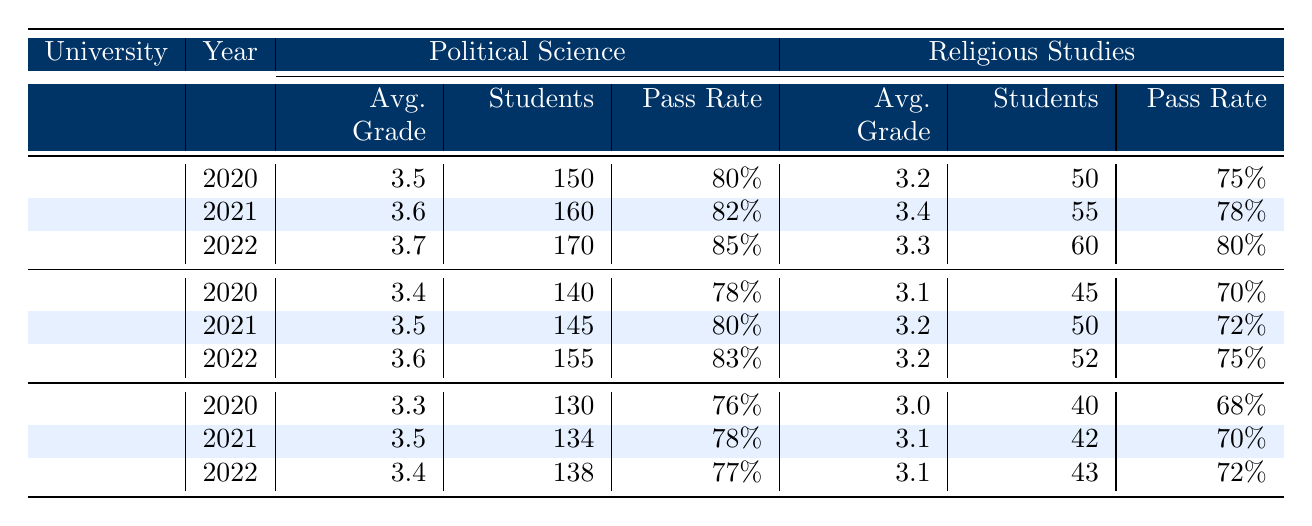What was the average grade for Political Science students at the University of Helsinki in 2021? The table shows that in 2021, the average grade for Political Science students at the University of Helsinki is 3.6.
Answer: 3.6 Which university had the highest pass rate for Religious Studies in 2020? By looking at the pass rates for Religious Studies in 2020, University of Helsinki has a pass rate of 75%, Tampere has 70%, and Turku has 68%. The highest pass rate is thus 75% from the University of Helsinki.
Answer: University of Helsinki What is the average pass rate for Political Science students across all universities in 2022? The pass rates for Political Science students in 2022 are: University of Helsinki (85%), Tampere (83%), and Turku (77%). Adding these rates gives 85 + 83 + 77 = 245. Dividing by the 3 universities gives an average pass rate of 245 / 3 = approximately 81.67%.
Answer: 81.67% Did the total number of Political Science students at Tampere University increase from 2020 to 2022? In 2020, there were 140 Political Science students, and in 2022 there were 155. Since 155 is greater than 140, the number of students increased.
Answer: Yes Which university had the lowest average grade for Religious Studies over the three years from 2020 to 2022? The average grades for Religious Studies are: University of Helsinki (3.2, 3.4, 3.3), Tampere (3.1, 3.2, 3.2), Turku (3.0, 3.1, 3.1). The lowest average grade is 3.0 from the University of Turku.
Answer: University of Turku What was the change in average grade for Political Science students at the University of Turku from 2020 to 2022? In 2020, the average grade was 3.3 and in 2022 it was 3.4. The change is calculated as 3.4 - 3.3 = 0.1.
Answer: 0.1 Is the total number of students in Religious Studies growing year by year for any university? Analyzing the total students in Religious Studies: University of Helsinki has 50 (2020), 55 (2021), 60 (2022); Tampere has 45 (2020), 50 (2021), 52 (2022); Turku has 40 (2020), 42 (2021), 43 (2022). All these have a growing trend, confirming growth.
Answer: Yes What university had the highest average performance in Political Science across all three years? Adding the average grades: Helsinki (3.5, 3.6, 3.7), Tampere (3.4, 3.5, 3.6), and Turku (3.3, 3.5, 3.4), we calculate: Helsinki's total is 10.8, Tampere's 10.5, and Turku's 10.2. Helsinki has the highest total of 10.8.
Answer: University of Helsinki 